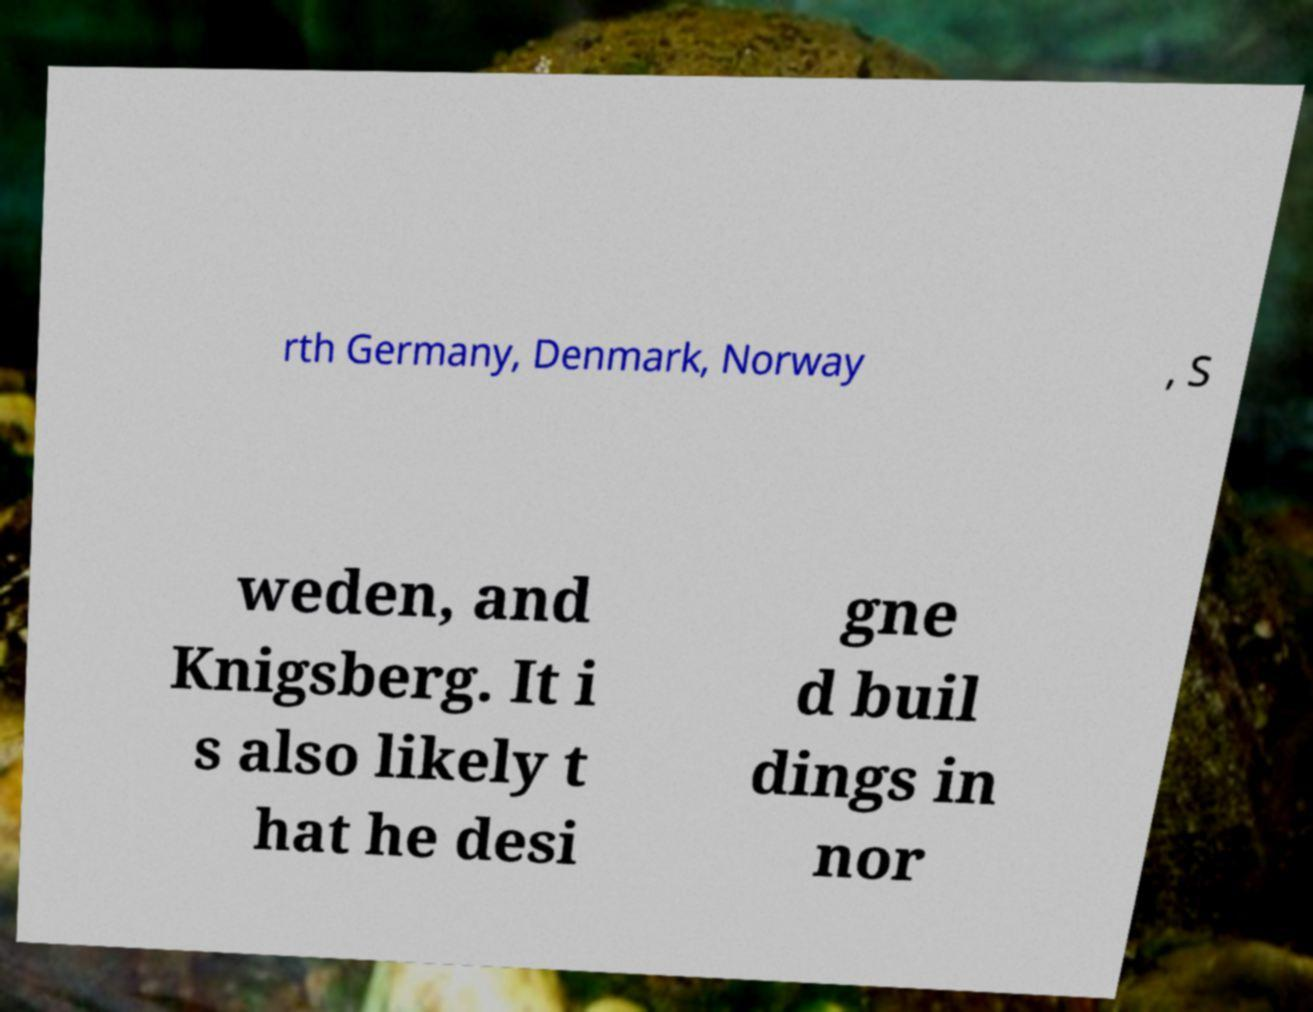Please read and relay the text visible in this image. What does it say? rth Germany, Denmark, Norway , S weden, and Knigsberg. It i s also likely t hat he desi gne d buil dings in nor 